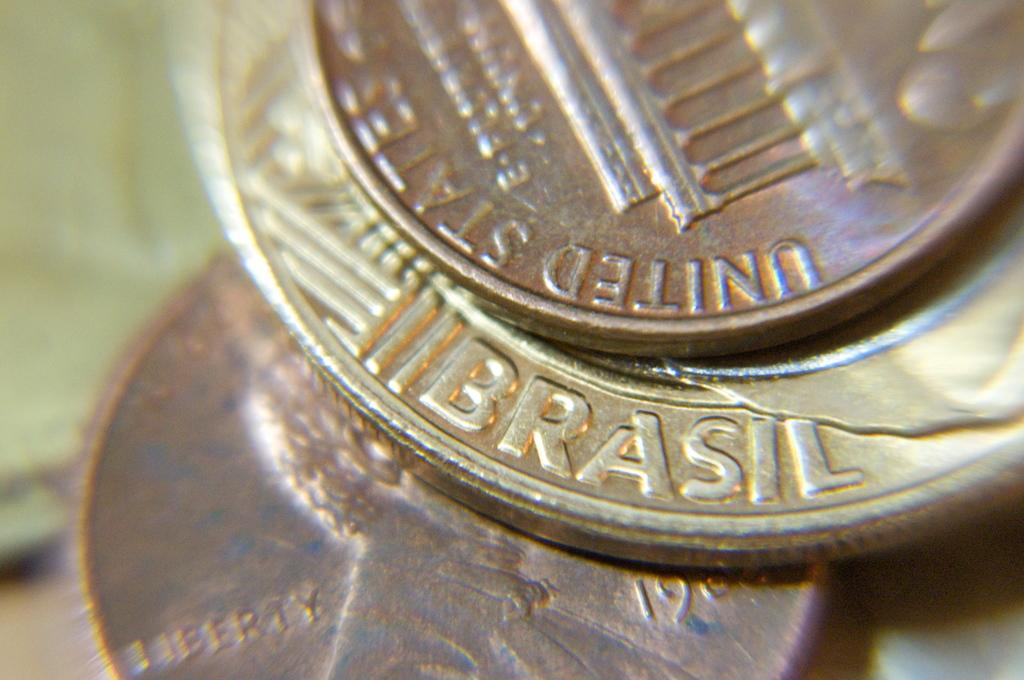<image>
Provide a brief description of the given image. A stack of American and Brazillian coins up close, one of the coins says Brazil at the bottom. 